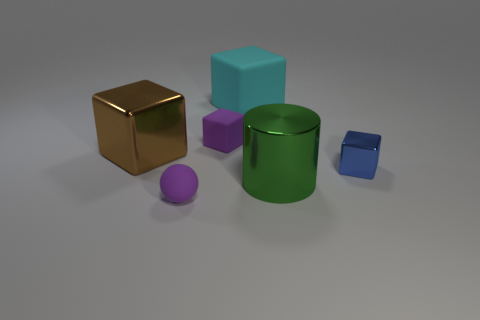How many tiny purple rubber things are there?
Your answer should be very brief. 2. How many objects are both left of the green metal cylinder and behind the green cylinder?
Your answer should be compact. 3. Are there any other things that are the same shape as the cyan object?
Offer a terse response. Yes. Do the small shiny thing and the large shiny object on the left side of the green cylinder have the same color?
Provide a succinct answer. No. What is the shape of the large shiny object that is on the right side of the purple cube?
Provide a succinct answer. Cylinder. What number of other objects are the same material as the green thing?
Offer a very short reply. 2. What is the small purple block made of?
Make the answer very short. Rubber. How many big things are either brown metal things or green cylinders?
Ensure brevity in your answer.  2. How many green metal things are on the left side of the green thing?
Give a very brief answer. 0. Is there a tiny cube of the same color as the shiny cylinder?
Offer a terse response. No. 